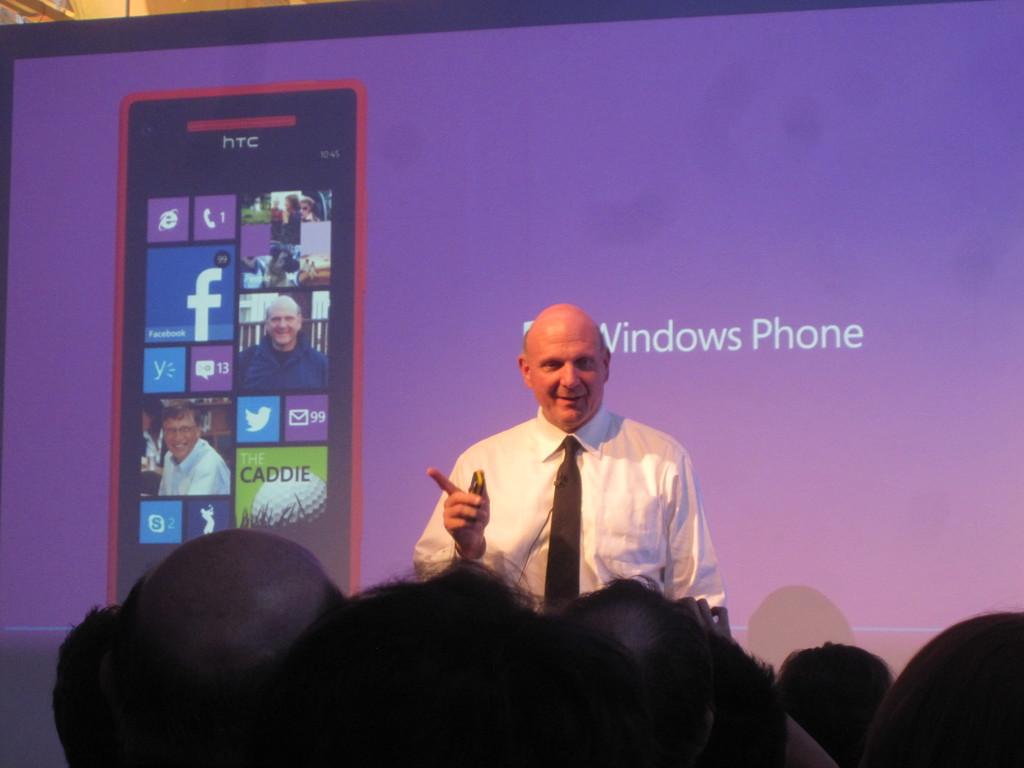What type of phone is being shown here?
Give a very brief answer. Windows phone. 